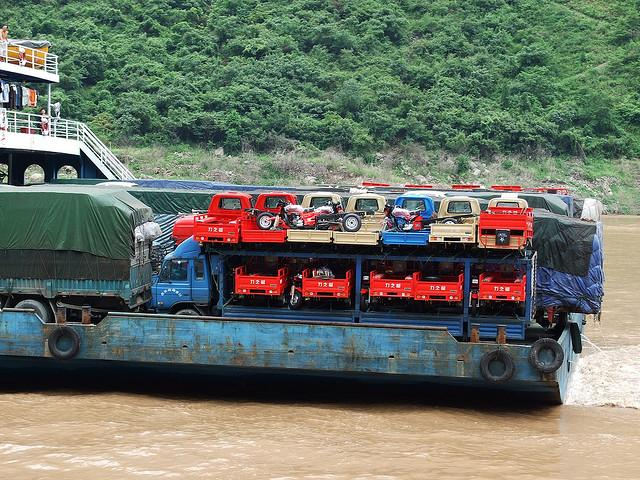Why are all the trucks in back of the boat? Please explain your reasoning. hauling them. They are going to be transported by means of water transport. 